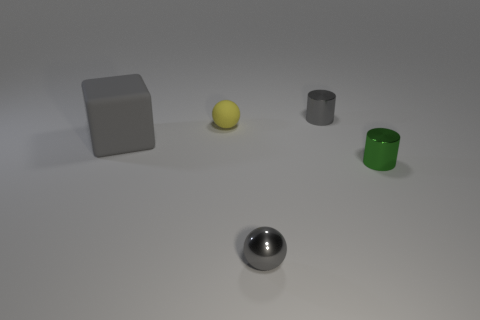What number of large objects are either gray metallic cylinders or balls?
Offer a very short reply. 0. What is the shape of the thing that is in front of the yellow sphere and left of the gray metallic ball?
Provide a short and direct response. Cube. Are the large block and the tiny yellow thing made of the same material?
Give a very brief answer. Yes. There is a rubber sphere that is the same size as the green metallic thing; what is its color?
Your response must be concise. Yellow. There is a object that is right of the gray sphere and in front of the matte ball; what color is it?
Keep it short and to the point. Green. There is a cylinder that is the same color as the cube; what is its size?
Keep it short and to the point. Small. There is a small object that is the same color as the small metal sphere; what shape is it?
Offer a terse response. Cylinder. There is a sphere in front of the gray object left of the small object that is in front of the small green object; how big is it?
Your answer should be very brief. Small. What is the material of the big thing?
Your answer should be very brief. Rubber. Is the material of the block the same as the small ball to the left of the metallic sphere?
Provide a succinct answer. Yes. 